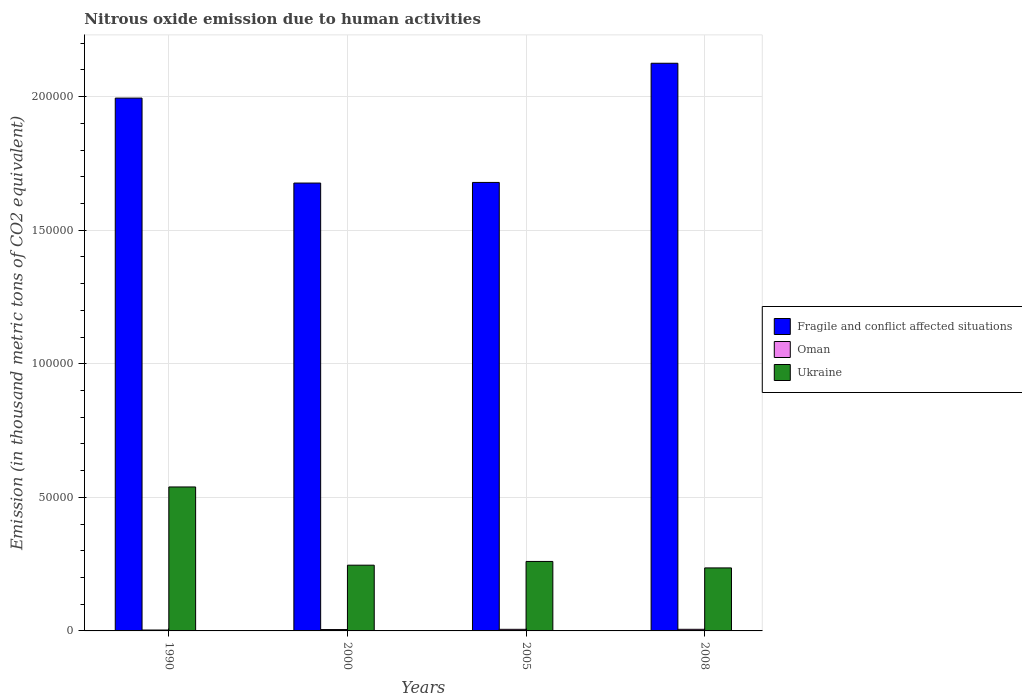How many different coloured bars are there?
Ensure brevity in your answer.  3. How many bars are there on the 2nd tick from the left?
Your response must be concise. 3. How many bars are there on the 3rd tick from the right?
Keep it short and to the point. 3. In how many cases, is the number of bars for a given year not equal to the number of legend labels?
Your answer should be very brief. 0. What is the amount of nitrous oxide emitted in Oman in 2000?
Provide a succinct answer. 510.6. Across all years, what is the maximum amount of nitrous oxide emitted in Fragile and conflict affected situations?
Ensure brevity in your answer.  2.12e+05. Across all years, what is the minimum amount of nitrous oxide emitted in Oman?
Make the answer very short. 338.2. What is the total amount of nitrous oxide emitted in Fragile and conflict affected situations in the graph?
Make the answer very short. 7.47e+05. What is the difference between the amount of nitrous oxide emitted in Ukraine in 1990 and that in 2008?
Keep it short and to the point. 3.03e+04. What is the difference between the amount of nitrous oxide emitted in Fragile and conflict affected situations in 2000 and the amount of nitrous oxide emitted in Ukraine in 2008?
Provide a succinct answer. 1.44e+05. What is the average amount of nitrous oxide emitted in Ukraine per year?
Ensure brevity in your answer.  3.20e+04. In the year 2005, what is the difference between the amount of nitrous oxide emitted in Fragile and conflict affected situations and amount of nitrous oxide emitted in Oman?
Provide a succinct answer. 1.67e+05. What is the ratio of the amount of nitrous oxide emitted in Oman in 1990 to that in 2008?
Your answer should be very brief. 0.56. What is the difference between the highest and the second highest amount of nitrous oxide emitted in Fragile and conflict affected situations?
Make the answer very short. 1.30e+04. What is the difference between the highest and the lowest amount of nitrous oxide emitted in Fragile and conflict affected situations?
Provide a succinct answer. 4.48e+04. What does the 1st bar from the left in 2008 represents?
Provide a succinct answer. Fragile and conflict affected situations. What does the 1st bar from the right in 2008 represents?
Keep it short and to the point. Ukraine. Are all the bars in the graph horizontal?
Offer a terse response. No. How many years are there in the graph?
Offer a very short reply. 4. Are the values on the major ticks of Y-axis written in scientific E-notation?
Your response must be concise. No. Where does the legend appear in the graph?
Give a very brief answer. Center right. How many legend labels are there?
Provide a succinct answer. 3. How are the legend labels stacked?
Provide a short and direct response. Vertical. What is the title of the graph?
Keep it short and to the point. Nitrous oxide emission due to human activities. Does "Belgium" appear as one of the legend labels in the graph?
Your answer should be very brief. No. What is the label or title of the X-axis?
Make the answer very short. Years. What is the label or title of the Y-axis?
Offer a very short reply. Emission (in thousand metric tons of CO2 equivalent). What is the Emission (in thousand metric tons of CO2 equivalent) of Fragile and conflict affected situations in 1990?
Give a very brief answer. 1.99e+05. What is the Emission (in thousand metric tons of CO2 equivalent) of Oman in 1990?
Make the answer very short. 338.2. What is the Emission (in thousand metric tons of CO2 equivalent) of Ukraine in 1990?
Your answer should be compact. 5.39e+04. What is the Emission (in thousand metric tons of CO2 equivalent) of Fragile and conflict affected situations in 2000?
Give a very brief answer. 1.68e+05. What is the Emission (in thousand metric tons of CO2 equivalent) of Oman in 2000?
Ensure brevity in your answer.  510.6. What is the Emission (in thousand metric tons of CO2 equivalent) of Ukraine in 2000?
Ensure brevity in your answer.  2.46e+04. What is the Emission (in thousand metric tons of CO2 equivalent) in Fragile and conflict affected situations in 2005?
Give a very brief answer. 1.68e+05. What is the Emission (in thousand metric tons of CO2 equivalent) of Oman in 2005?
Your answer should be compact. 597.3. What is the Emission (in thousand metric tons of CO2 equivalent) in Ukraine in 2005?
Your answer should be very brief. 2.60e+04. What is the Emission (in thousand metric tons of CO2 equivalent) in Fragile and conflict affected situations in 2008?
Offer a terse response. 2.12e+05. What is the Emission (in thousand metric tons of CO2 equivalent) in Oman in 2008?
Provide a succinct answer. 606.8. What is the Emission (in thousand metric tons of CO2 equivalent) of Ukraine in 2008?
Your answer should be compact. 2.36e+04. Across all years, what is the maximum Emission (in thousand metric tons of CO2 equivalent) of Fragile and conflict affected situations?
Provide a short and direct response. 2.12e+05. Across all years, what is the maximum Emission (in thousand metric tons of CO2 equivalent) of Oman?
Keep it short and to the point. 606.8. Across all years, what is the maximum Emission (in thousand metric tons of CO2 equivalent) in Ukraine?
Provide a succinct answer. 5.39e+04. Across all years, what is the minimum Emission (in thousand metric tons of CO2 equivalent) in Fragile and conflict affected situations?
Offer a terse response. 1.68e+05. Across all years, what is the minimum Emission (in thousand metric tons of CO2 equivalent) in Oman?
Your answer should be compact. 338.2. Across all years, what is the minimum Emission (in thousand metric tons of CO2 equivalent) of Ukraine?
Keep it short and to the point. 2.36e+04. What is the total Emission (in thousand metric tons of CO2 equivalent) of Fragile and conflict affected situations in the graph?
Provide a succinct answer. 7.47e+05. What is the total Emission (in thousand metric tons of CO2 equivalent) in Oman in the graph?
Ensure brevity in your answer.  2052.9. What is the total Emission (in thousand metric tons of CO2 equivalent) of Ukraine in the graph?
Ensure brevity in your answer.  1.28e+05. What is the difference between the Emission (in thousand metric tons of CO2 equivalent) of Fragile and conflict affected situations in 1990 and that in 2000?
Offer a terse response. 3.18e+04. What is the difference between the Emission (in thousand metric tons of CO2 equivalent) of Oman in 1990 and that in 2000?
Offer a very short reply. -172.4. What is the difference between the Emission (in thousand metric tons of CO2 equivalent) in Ukraine in 1990 and that in 2000?
Keep it short and to the point. 2.93e+04. What is the difference between the Emission (in thousand metric tons of CO2 equivalent) in Fragile and conflict affected situations in 1990 and that in 2005?
Offer a very short reply. 3.16e+04. What is the difference between the Emission (in thousand metric tons of CO2 equivalent) of Oman in 1990 and that in 2005?
Your response must be concise. -259.1. What is the difference between the Emission (in thousand metric tons of CO2 equivalent) in Ukraine in 1990 and that in 2005?
Ensure brevity in your answer.  2.79e+04. What is the difference between the Emission (in thousand metric tons of CO2 equivalent) of Fragile and conflict affected situations in 1990 and that in 2008?
Give a very brief answer. -1.30e+04. What is the difference between the Emission (in thousand metric tons of CO2 equivalent) of Oman in 1990 and that in 2008?
Offer a very short reply. -268.6. What is the difference between the Emission (in thousand metric tons of CO2 equivalent) in Ukraine in 1990 and that in 2008?
Keep it short and to the point. 3.03e+04. What is the difference between the Emission (in thousand metric tons of CO2 equivalent) of Fragile and conflict affected situations in 2000 and that in 2005?
Provide a succinct answer. -238.1. What is the difference between the Emission (in thousand metric tons of CO2 equivalent) of Oman in 2000 and that in 2005?
Offer a very short reply. -86.7. What is the difference between the Emission (in thousand metric tons of CO2 equivalent) of Ukraine in 2000 and that in 2005?
Your response must be concise. -1402.1. What is the difference between the Emission (in thousand metric tons of CO2 equivalent) of Fragile and conflict affected situations in 2000 and that in 2008?
Your answer should be very brief. -4.48e+04. What is the difference between the Emission (in thousand metric tons of CO2 equivalent) of Oman in 2000 and that in 2008?
Make the answer very short. -96.2. What is the difference between the Emission (in thousand metric tons of CO2 equivalent) in Ukraine in 2000 and that in 2008?
Provide a short and direct response. 1024.6. What is the difference between the Emission (in thousand metric tons of CO2 equivalent) in Fragile and conflict affected situations in 2005 and that in 2008?
Ensure brevity in your answer.  -4.46e+04. What is the difference between the Emission (in thousand metric tons of CO2 equivalent) in Ukraine in 2005 and that in 2008?
Give a very brief answer. 2426.7. What is the difference between the Emission (in thousand metric tons of CO2 equivalent) in Fragile and conflict affected situations in 1990 and the Emission (in thousand metric tons of CO2 equivalent) in Oman in 2000?
Make the answer very short. 1.99e+05. What is the difference between the Emission (in thousand metric tons of CO2 equivalent) in Fragile and conflict affected situations in 1990 and the Emission (in thousand metric tons of CO2 equivalent) in Ukraine in 2000?
Offer a very short reply. 1.75e+05. What is the difference between the Emission (in thousand metric tons of CO2 equivalent) of Oman in 1990 and the Emission (in thousand metric tons of CO2 equivalent) of Ukraine in 2000?
Your response must be concise. -2.43e+04. What is the difference between the Emission (in thousand metric tons of CO2 equivalent) of Fragile and conflict affected situations in 1990 and the Emission (in thousand metric tons of CO2 equivalent) of Oman in 2005?
Provide a short and direct response. 1.99e+05. What is the difference between the Emission (in thousand metric tons of CO2 equivalent) in Fragile and conflict affected situations in 1990 and the Emission (in thousand metric tons of CO2 equivalent) in Ukraine in 2005?
Your answer should be compact. 1.73e+05. What is the difference between the Emission (in thousand metric tons of CO2 equivalent) in Oman in 1990 and the Emission (in thousand metric tons of CO2 equivalent) in Ukraine in 2005?
Your answer should be very brief. -2.57e+04. What is the difference between the Emission (in thousand metric tons of CO2 equivalent) of Fragile and conflict affected situations in 1990 and the Emission (in thousand metric tons of CO2 equivalent) of Oman in 2008?
Your answer should be very brief. 1.99e+05. What is the difference between the Emission (in thousand metric tons of CO2 equivalent) of Fragile and conflict affected situations in 1990 and the Emission (in thousand metric tons of CO2 equivalent) of Ukraine in 2008?
Your answer should be very brief. 1.76e+05. What is the difference between the Emission (in thousand metric tons of CO2 equivalent) of Oman in 1990 and the Emission (in thousand metric tons of CO2 equivalent) of Ukraine in 2008?
Keep it short and to the point. -2.32e+04. What is the difference between the Emission (in thousand metric tons of CO2 equivalent) of Fragile and conflict affected situations in 2000 and the Emission (in thousand metric tons of CO2 equivalent) of Oman in 2005?
Your answer should be very brief. 1.67e+05. What is the difference between the Emission (in thousand metric tons of CO2 equivalent) of Fragile and conflict affected situations in 2000 and the Emission (in thousand metric tons of CO2 equivalent) of Ukraine in 2005?
Provide a succinct answer. 1.42e+05. What is the difference between the Emission (in thousand metric tons of CO2 equivalent) in Oman in 2000 and the Emission (in thousand metric tons of CO2 equivalent) in Ukraine in 2005?
Your answer should be very brief. -2.55e+04. What is the difference between the Emission (in thousand metric tons of CO2 equivalent) in Fragile and conflict affected situations in 2000 and the Emission (in thousand metric tons of CO2 equivalent) in Oman in 2008?
Your response must be concise. 1.67e+05. What is the difference between the Emission (in thousand metric tons of CO2 equivalent) of Fragile and conflict affected situations in 2000 and the Emission (in thousand metric tons of CO2 equivalent) of Ukraine in 2008?
Your answer should be very brief. 1.44e+05. What is the difference between the Emission (in thousand metric tons of CO2 equivalent) in Oman in 2000 and the Emission (in thousand metric tons of CO2 equivalent) in Ukraine in 2008?
Give a very brief answer. -2.31e+04. What is the difference between the Emission (in thousand metric tons of CO2 equivalent) of Fragile and conflict affected situations in 2005 and the Emission (in thousand metric tons of CO2 equivalent) of Oman in 2008?
Give a very brief answer. 1.67e+05. What is the difference between the Emission (in thousand metric tons of CO2 equivalent) of Fragile and conflict affected situations in 2005 and the Emission (in thousand metric tons of CO2 equivalent) of Ukraine in 2008?
Give a very brief answer. 1.44e+05. What is the difference between the Emission (in thousand metric tons of CO2 equivalent) of Oman in 2005 and the Emission (in thousand metric tons of CO2 equivalent) of Ukraine in 2008?
Your answer should be compact. -2.30e+04. What is the average Emission (in thousand metric tons of CO2 equivalent) in Fragile and conflict affected situations per year?
Your response must be concise. 1.87e+05. What is the average Emission (in thousand metric tons of CO2 equivalent) of Oman per year?
Give a very brief answer. 513.23. What is the average Emission (in thousand metric tons of CO2 equivalent) in Ukraine per year?
Provide a succinct answer. 3.20e+04. In the year 1990, what is the difference between the Emission (in thousand metric tons of CO2 equivalent) in Fragile and conflict affected situations and Emission (in thousand metric tons of CO2 equivalent) in Oman?
Your answer should be very brief. 1.99e+05. In the year 1990, what is the difference between the Emission (in thousand metric tons of CO2 equivalent) in Fragile and conflict affected situations and Emission (in thousand metric tons of CO2 equivalent) in Ukraine?
Give a very brief answer. 1.46e+05. In the year 1990, what is the difference between the Emission (in thousand metric tons of CO2 equivalent) of Oman and Emission (in thousand metric tons of CO2 equivalent) of Ukraine?
Make the answer very short. -5.35e+04. In the year 2000, what is the difference between the Emission (in thousand metric tons of CO2 equivalent) of Fragile and conflict affected situations and Emission (in thousand metric tons of CO2 equivalent) of Oman?
Give a very brief answer. 1.67e+05. In the year 2000, what is the difference between the Emission (in thousand metric tons of CO2 equivalent) in Fragile and conflict affected situations and Emission (in thousand metric tons of CO2 equivalent) in Ukraine?
Offer a very short reply. 1.43e+05. In the year 2000, what is the difference between the Emission (in thousand metric tons of CO2 equivalent) of Oman and Emission (in thousand metric tons of CO2 equivalent) of Ukraine?
Give a very brief answer. -2.41e+04. In the year 2005, what is the difference between the Emission (in thousand metric tons of CO2 equivalent) in Fragile and conflict affected situations and Emission (in thousand metric tons of CO2 equivalent) in Oman?
Offer a very short reply. 1.67e+05. In the year 2005, what is the difference between the Emission (in thousand metric tons of CO2 equivalent) of Fragile and conflict affected situations and Emission (in thousand metric tons of CO2 equivalent) of Ukraine?
Keep it short and to the point. 1.42e+05. In the year 2005, what is the difference between the Emission (in thousand metric tons of CO2 equivalent) of Oman and Emission (in thousand metric tons of CO2 equivalent) of Ukraine?
Your response must be concise. -2.54e+04. In the year 2008, what is the difference between the Emission (in thousand metric tons of CO2 equivalent) in Fragile and conflict affected situations and Emission (in thousand metric tons of CO2 equivalent) in Oman?
Keep it short and to the point. 2.12e+05. In the year 2008, what is the difference between the Emission (in thousand metric tons of CO2 equivalent) in Fragile and conflict affected situations and Emission (in thousand metric tons of CO2 equivalent) in Ukraine?
Provide a short and direct response. 1.89e+05. In the year 2008, what is the difference between the Emission (in thousand metric tons of CO2 equivalent) of Oman and Emission (in thousand metric tons of CO2 equivalent) of Ukraine?
Your response must be concise. -2.30e+04. What is the ratio of the Emission (in thousand metric tons of CO2 equivalent) of Fragile and conflict affected situations in 1990 to that in 2000?
Provide a succinct answer. 1.19. What is the ratio of the Emission (in thousand metric tons of CO2 equivalent) of Oman in 1990 to that in 2000?
Your response must be concise. 0.66. What is the ratio of the Emission (in thousand metric tons of CO2 equivalent) in Ukraine in 1990 to that in 2000?
Ensure brevity in your answer.  2.19. What is the ratio of the Emission (in thousand metric tons of CO2 equivalent) in Fragile and conflict affected situations in 1990 to that in 2005?
Offer a terse response. 1.19. What is the ratio of the Emission (in thousand metric tons of CO2 equivalent) of Oman in 1990 to that in 2005?
Offer a very short reply. 0.57. What is the ratio of the Emission (in thousand metric tons of CO2 equivalent) of Ukraine in 1990 to that in 2005?
Your response must be concise. 2.07. What is the ratio of the Emission (in thousand metric tons of CO2 equivalent) in Fragile and conflict affected situations in 1990 to that in 2008?
Your answer should be compact. 0.94. What is the ratio of the Emission (in thousand metric tons of CO2 equivalent) of Oman in 1990 to that in 2008?
Provide a short and direct response. 0.56. What is the ratio of the Emission (in thousand metric tons of CO2 equivalent) in Ukraine in 1990 to that in 2008?
Keep it short and to the point. 2.29. What is the ratio of the Emission (in thousand metric tons of CO2 equivalent) in Fragile and conflict affected situations in 2000 to that in 2005?
Make the answer very short. 1. What is the ratio of the Emission (in thousand metric tons of CO2 equivalent) in Oman in 2000 to that in 2005?
Offer a very short reply. 0.85. What is the ratio of the Emission (in thousand metric tons of CO2 equivalent) of Ukraine in 2000 to that in 2005?
Give a very brief answer. 0.95. What is the ratio of the Emission (in thousand metric tons of CO2 equivalent) of Fragile and conflict affected situations in 2000 to that in 2008?
Give a very brief answer. 0.79. What is the ratio of the Emission (in thousand metric tons of CO2 equivalent) of Oman in 2000 to that in 2008?
Keep it short and to the point. 0.84. What is the ratio of the Emission (in thousand metric tons of CO2 equivalent) of Ukraine in 2000 to that in 2008?
Give a very brief answer. 1.04. What is the ratio of the Emission (in thousand metric tons of CO2 equivalent) in Fragile and conflict affected situations in 2005 to that in 2008?
Offer a terse response. 0.79. What is the ratio of the Emission (in thousand metric tons of CO2 equivalent) of Oman in 2005 to that in 2008?
Ensure brevity in your answer.  0.98. What is the ratio of the Emission (in thousand metric tons of CO2 equivalent) in Ukraine in 2005 to that in 2008?
Give a very brief answer. 1.1. What is the difference between the highest and the second highest Emission (in thousand metric tons of CO2 equivalent) of Fragile and conflict affected situations?
Your answer should be very brief. 1.30e+04. What is the difference between the highest and the second highest Emission (in thousand metric tons of CO2 equivalent) of Oman?
Keep it short and to the point. 9.5. What is the difference between the highest and the second highest Emission (in thousand metric tons of CO2 equivalent) of Ukraine?
Your response must be concise. 2.79e+04. What is the difference between the highest and the lowest Emission (in thousand metric tons of CO2 equivalent) of Fragile and conflict affected situations?
Offer a very short reply. 4.48e+04. What is the difference between the highest and the lowest Emission (in thousand metric tons of CO2 equivalent) of Oman?
Your answer should be very brief. 268.6. What is the difference between the highest and the lowest Emission (in thousand metric tons of CO2 equivalent) in Ukraine?
Give a very brief answer. 3.03e+04. 